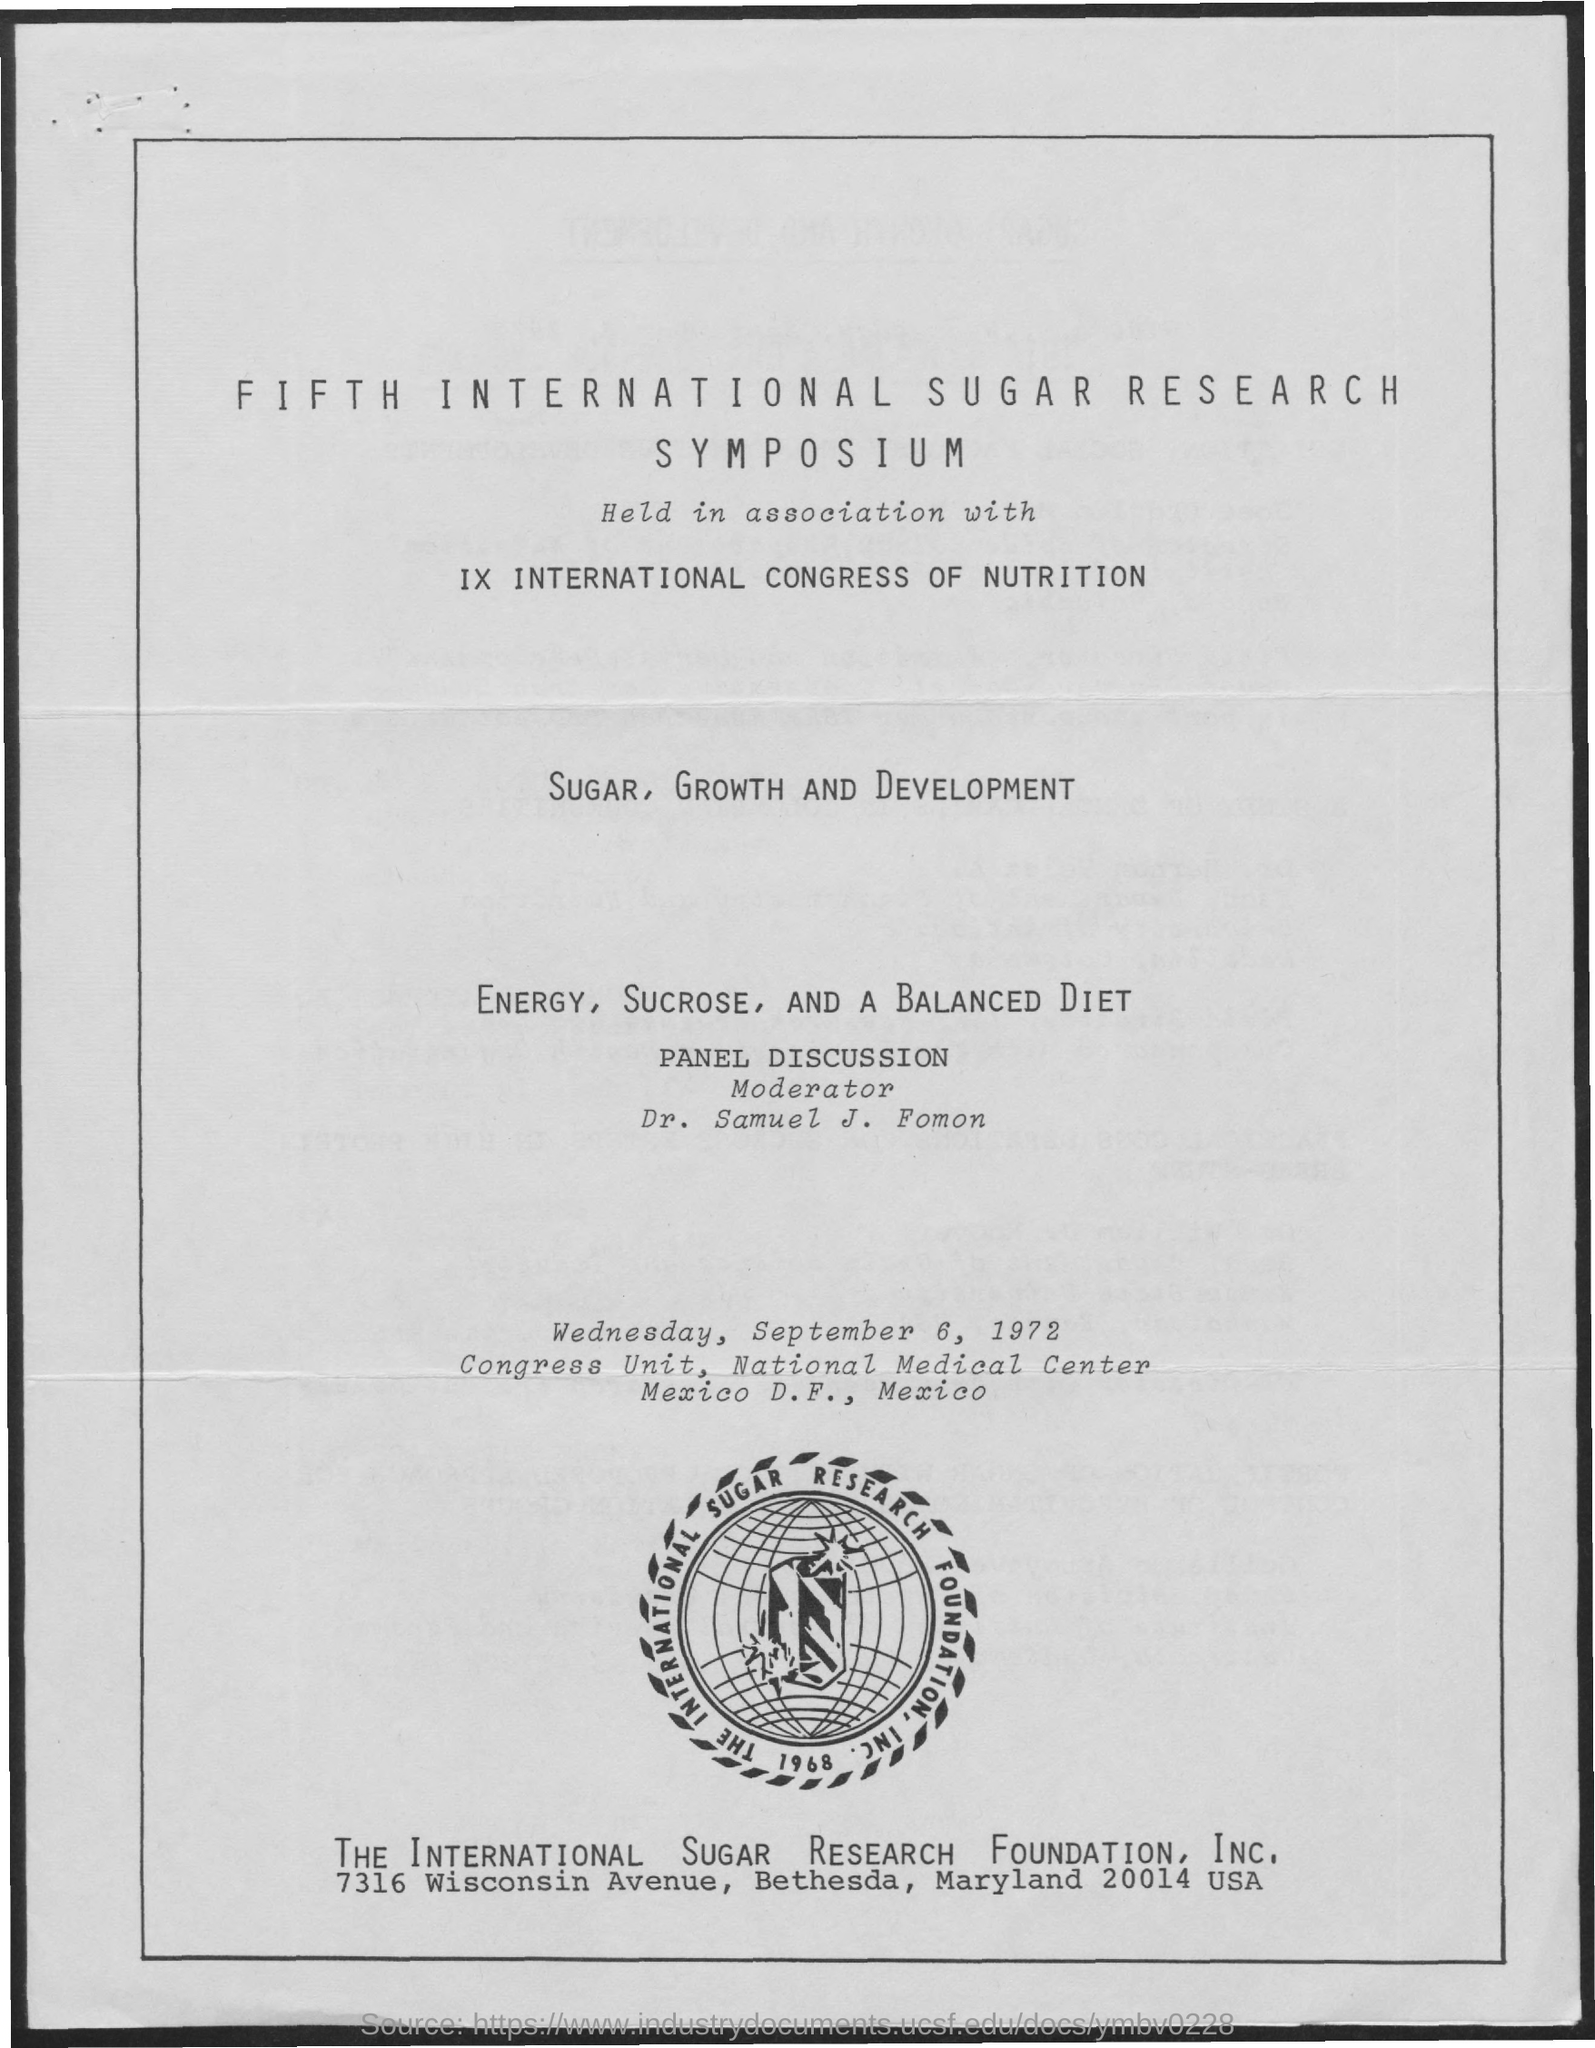What is the year in which international sugar research foundation was established?
Keep it short and to the point. 1968. 